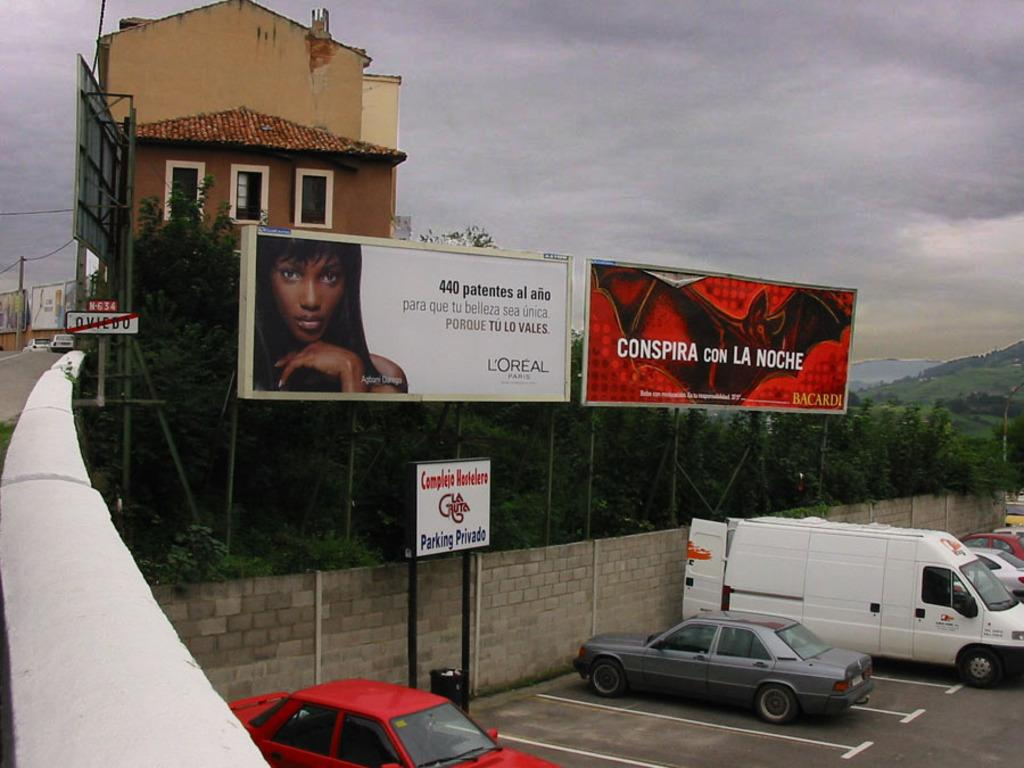<image>
Render a clear and concise summary of the photo. Billboards for L'Oréal and Bacardi are over a parking lot. 